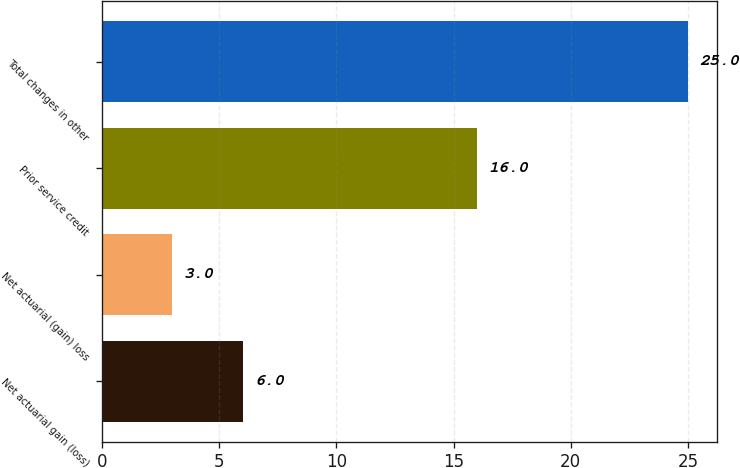Convert chart. <chart><loc_0><loc_0><loc_500><loc_500><bar_chart><fcel>Net actuarial gain (loss)<fcel>Net actuarial (gain) loss<fcel>Prior service credit<fcel>Total changes in other<nl><fcel>6<fcel>3<fcel>16<fcel>25<nl></chart> 